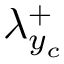Convert formula to latex. <formula><loc_0><loc_0><loc_500><loc_500>{ \lambda } _ { y _ { c } } ^ { + }</formula> 